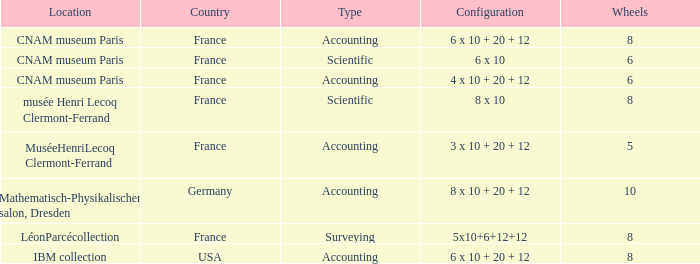What average wheels has accounting as the type, with IBM Collection as the location? 8.0. Help me parse the entirety of this table. {'header': ['Location', 'Country', 'Type', 'Configuration', 'Wheels'], 'rows': [['CNAM museum Paris', 'France', 'Accounting', '6 x 10 + 20 + 12', '8'], ['CNAM museum Paris', 'France', 'Scientific', '6 x 10', '6'], ['CNAM museum Paris', 'France', 'Accounting', '4 x 10 + 20 + 12', '6'], ['musée Henri Lecoq Clermont-Ferrand', 'France', 'Scientific', '8 x 10', '8'], ['MuséeHenriLecoq Clermont-Ferrand', 'France', 'Accounting', '3 x 10 + 20 + 12', '5'], ['Mathematisch-Physikalischer salon, Dresden', 'Germany', 'Accounting', '8 x 10 + 20 + 12', '10'], ['LéonParcécollection', 'France', 'Surveying', '5x10+6+12+12', '8'], ['IBM collection', 'USA', 'Accounting', '6 x 10 + 20 + 12', '8']]} 